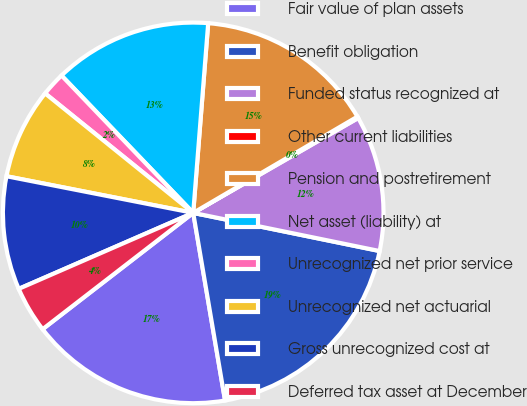<chart> <loc_0><loc_0><loc_500><loc_500><pie_chart><fcel>Fair value of plan assets<fcel>Benefit obligation<fcel>Funded status recognized at<fcel>Other current liabilities<fcel>Pension and postretirement<fcel>Net asset (liability) at<fcel>Unrecognized net prior service<fcel>Unrecognized net actuarial<fcel>Gross unrecognized cost at<fcel>Deferred tax asset at December<nl><fcel>17.21%<fcel>19.11%<fcel>11.52%<fcel>0.13%<fcel>15.31%<fcel>13.42%<fcel>2.03%<fcel>7.72%<fcel>9.62%<fcel>3.93%<nl></chart> 